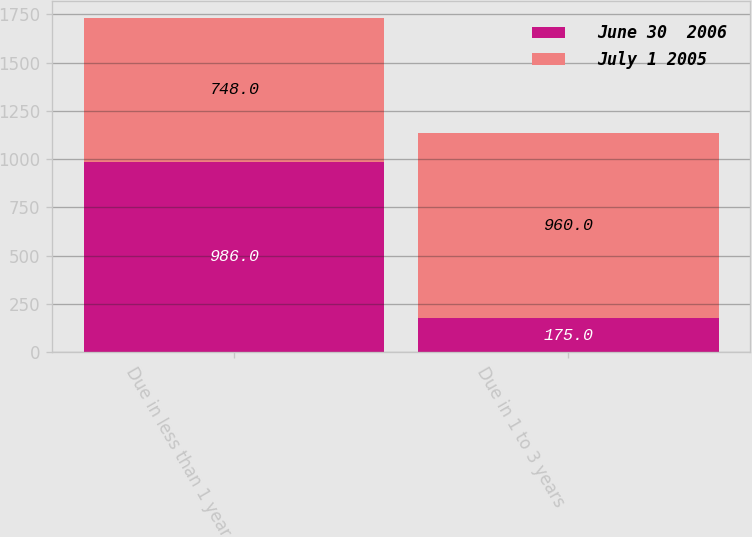<chart> <loc_0><loc_0><loc_500><loc_500><stacked_bar_chart><ecel><fcel>Due in less than 1 year<fcel>Due in 1 to 3 years<nl><fcel>June 30  2006<fcel>986<fcel>175<nl><fcel>July 1 2005<fcel>748<fcel>960<nl></chart> 